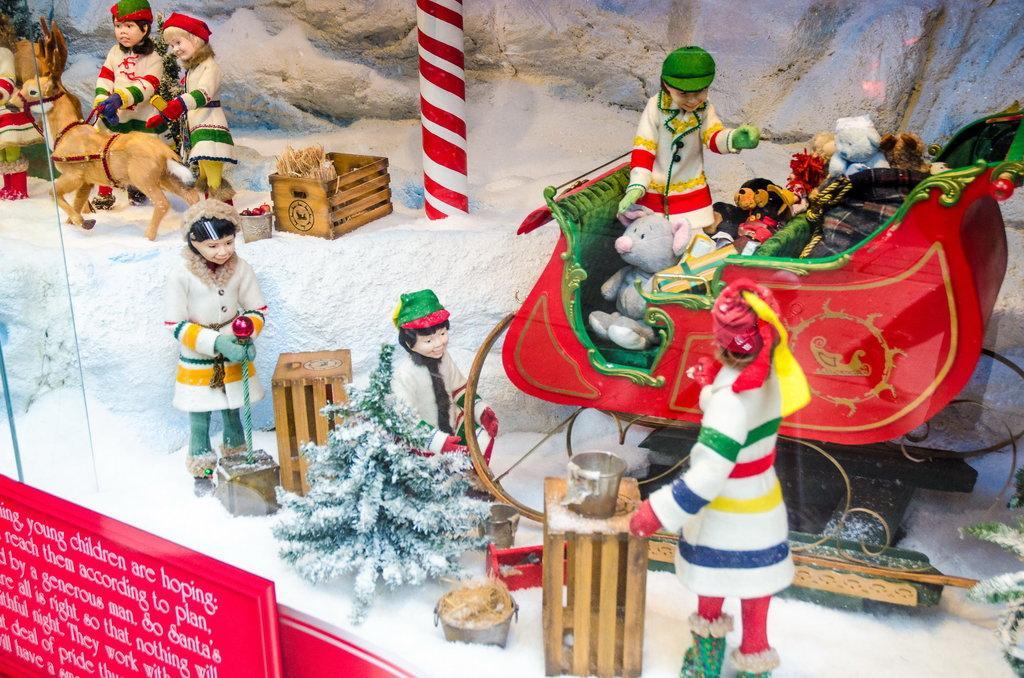Describe this image in one or two sentences. In this image we can see many toys. There is a display board on which some text written on it. 